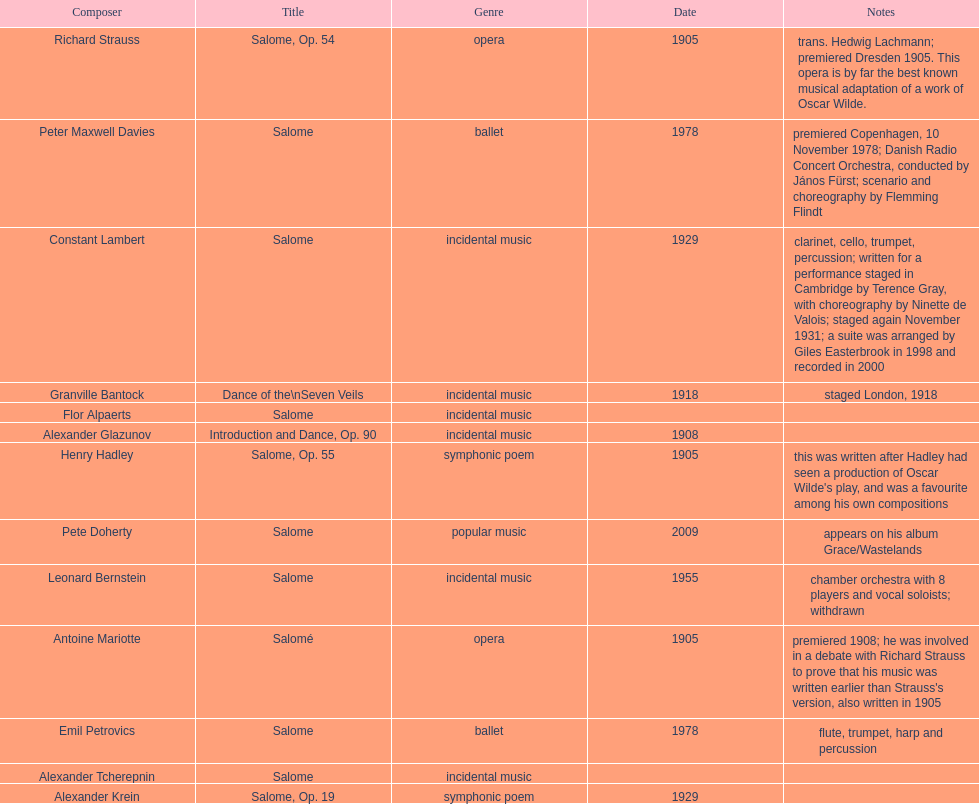Which composer produced his title after 2001? Pete Doherty. 